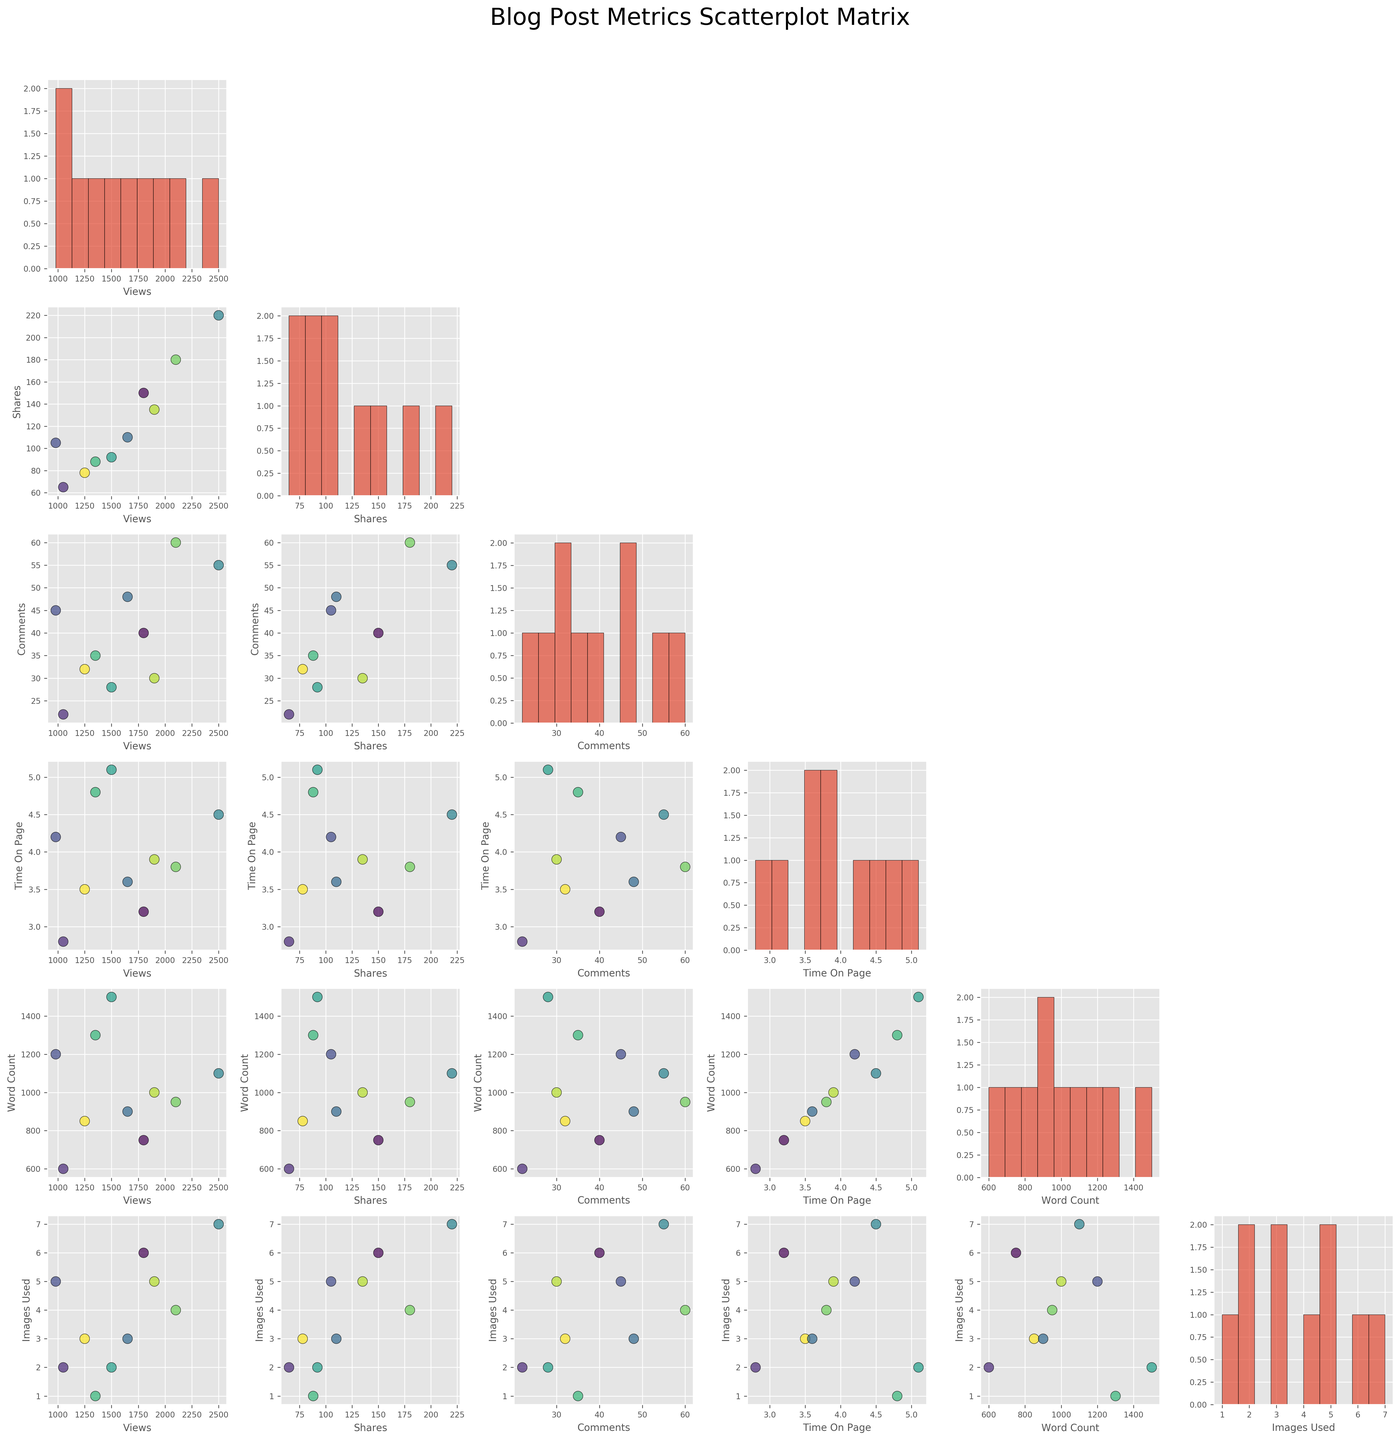How many different colors are used in the scatterplot matrix? The plot uses colors to categorize the posting times. By counting the different colors used in the scatterplot matrix, we can determine the number of categories.
Answer: 10 Which metric variable shows a positive correlation with 'views'? To identify a positive correlation, look for upward trending scatterplots involving the 'views' variable.
Answer: 'shares' What is the approximate time on page for the blog post with the highest number of views? Find the scatterplot of 'views' versus 'time on page' and locate the highest point on the 'views' axis to determine its corresponding 'time on page'.
Answer: 4.5 minutes Which two blog post metrics appear to have the most scattered relationship? To find the most scattered relationship, look for the scatterplot with the points most widely dispersed without a clear cluster pattern.
Answer: 'views' and 'images_used' Is there any variable with a histogram that appears to follow a nearly uniform distribution? Look at the histograms along the diagonal of the scatterplot matrix to identify one that looks relatively uniform, with bars of similar height.
Answer: 'images_used' What can be said about the relationship between 'word count' and 'time on page'? Look at the scatterplot of 'word count' versus 'time on page'. If there is an upward trend, this suggests a positive relationship.
Answer: Positive correlation Which variable has the least variability in its histogram? Inspect the histograms and identify the one with the least range between its smallest and largest values, indicating less variability.
Answer: 'time_on_page' Do posts with higher 'word count' generally receive more 'comments'? By examining the scatterplot of 'word count' versus 'comments', you can determine if higher word counts are associated with more comments.
Answer: Yes How does 'images used' relate to 'shares' in the posts? Look at the scatterplot of 'images used' versus 'shares' to observe if there's any discernible trend or pattern that would indicate their relationship.
Answer: Positive trend Which two variables show a negative correlation with each other? Identify the scatterplot where one variable increases while the other decreases to find a negative correlation.
Answer: 'images_used' and 'views' 